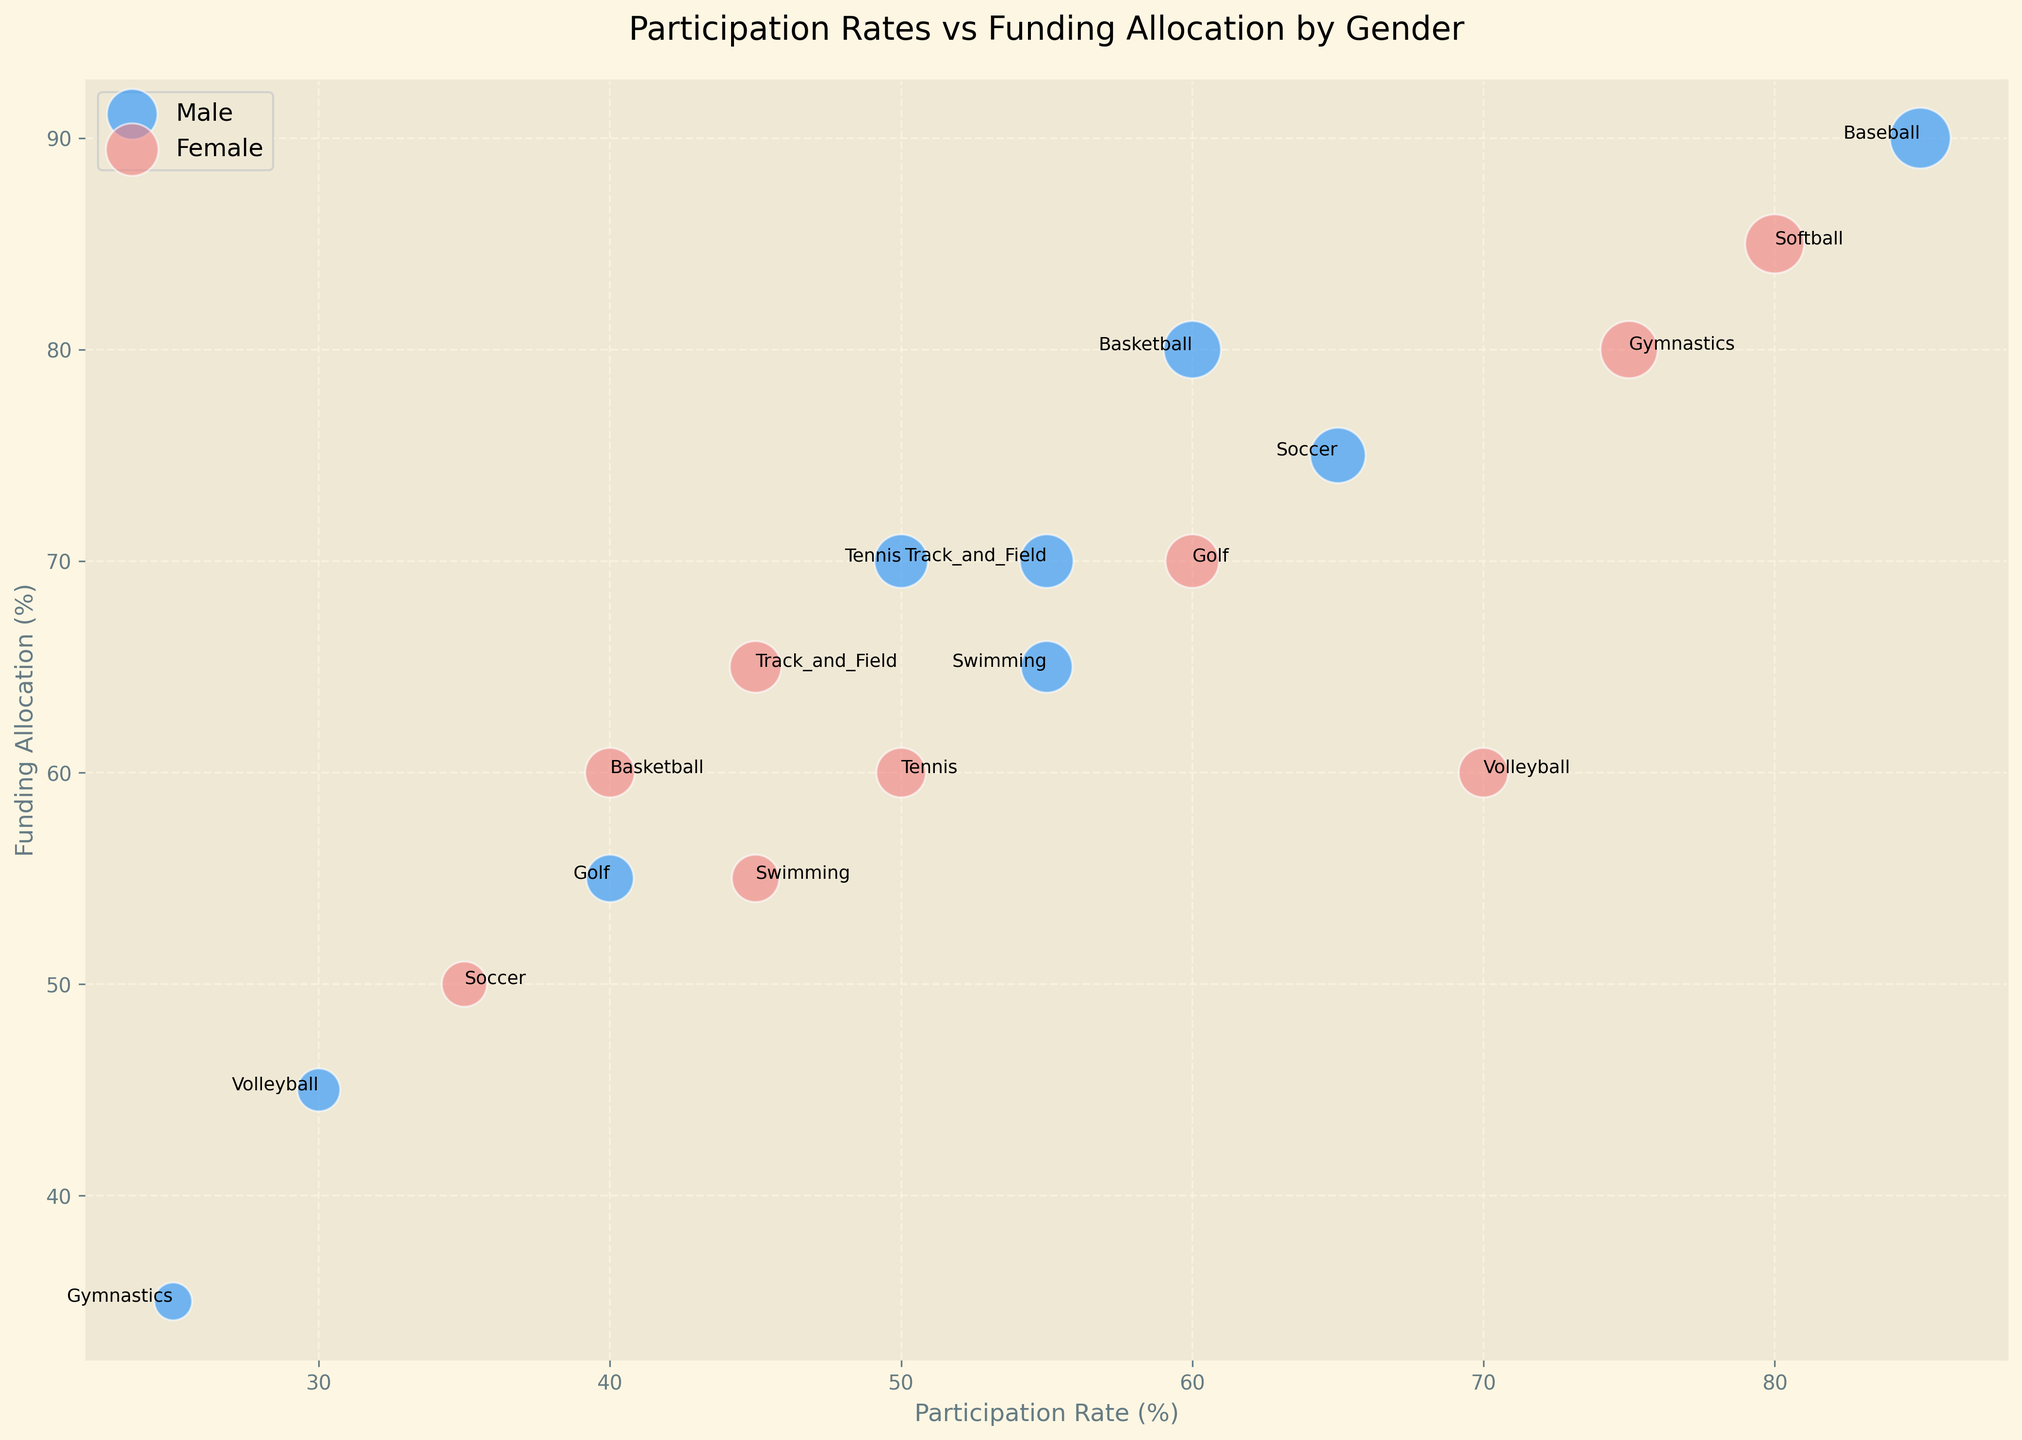What sport has the highest funding allocation for males, and what is the participation rate for that sport? First, identify the sport with the highest funding allocation for males by looking at the size of the blue bubbles. The largest blue bubble corresponds to Baseball, where the funding allocation is 90%. The participation rate for Baseball is 85%.
Answer: Baseball, 85% Which gender has a higher participation rate in Volleyball, and what is the difference in participation rates between genders? Check the participation rates for Volleyball for both genders. Females have a participation rate of 70%, and males have a participation rate of 30%. The difference is 70% - 30% = 40%.
Answer: Female, 40% For which sport do males and females have the same participation rate, and how does their funding allocation differ? Look for the sport where the participation rates are the same for both genders. For Tennis, both males and females have a 50% participation rate. The funding allocation for males is 70%, while for females it is 60%. The difference in funding allocation is 70% - 60% = 10%.
Answer: Tennis, 10% Which sport has the largest disparity in participation rate between genders, and what is the disparity? Identify the sport with the largest difference in participation rates between genders by checking each pair. Gymnastics has the largest disparity: males at 25% and females at 75%. The disparity is 75% - 25% = 50%.
Answer: Gymnastics, 50% What is the average funding allocation for female athletes across all sports? Sum the funding allocation percentages for female athletes across all sports and divide by the number of sports. (60 + 50 + 60 + 55 + 60 + 65 + 85 + 80 + 70) = 585. There are 9 sports listed. The average is 585 / 9 ≈ 65%.
Answer: 65% Compare the funding allocation for male and female athletes in Swimming. Which one is higher and by how much? For Swimming, check the funding allocations for both genders. Males have a funding allocation of 65%, and females have 55%. The difference is 65% - 55% = 10%. Males have higher funding by 10%.
Answer: Male, 10% Are there any sports where the funding allocation is equal for both males and females, and if so, which ones? Check for sports where both genders have the same funding allocation. There are no sports where the funding allocations for males and females are exactly the same in the given data.
Answer: None Which sport has the smallest funding allocation for male athletes, and what is the participation rate for that sport? Identify the sport with the smallest blue bubble (smallest funding allocation for males). Gymnastics has the smallest funding allocation for male athletes at 35%. The participation rate for Gymnastics is 25%.
Answer: Gymnastics, 25% 